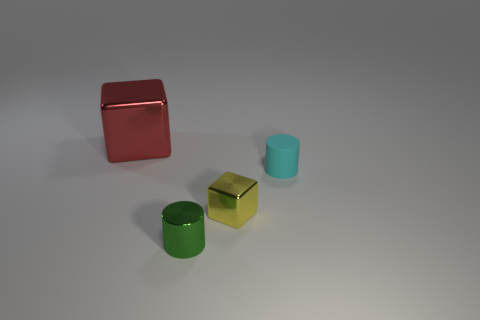Add 1 cyan rubber cylinders. How many objects exist? 5 Subtract all cyan cylinders. How many cylinders are left? 1 Subtract all small green cylinders. Subtract all small green objects. How many objects are left? 2 Add 4 red things. How many red things are left? 5 Add 4 small rubber blocks. How many small rubber blocks exist? 4 Subtract 0 yellow balls. How many objects are left? 4 Subtract 1 cylinders. How many cylinders are left? 1 Subtract all gray cylinders. Subtract all cyan spheres. How many cylinders are left? 2 